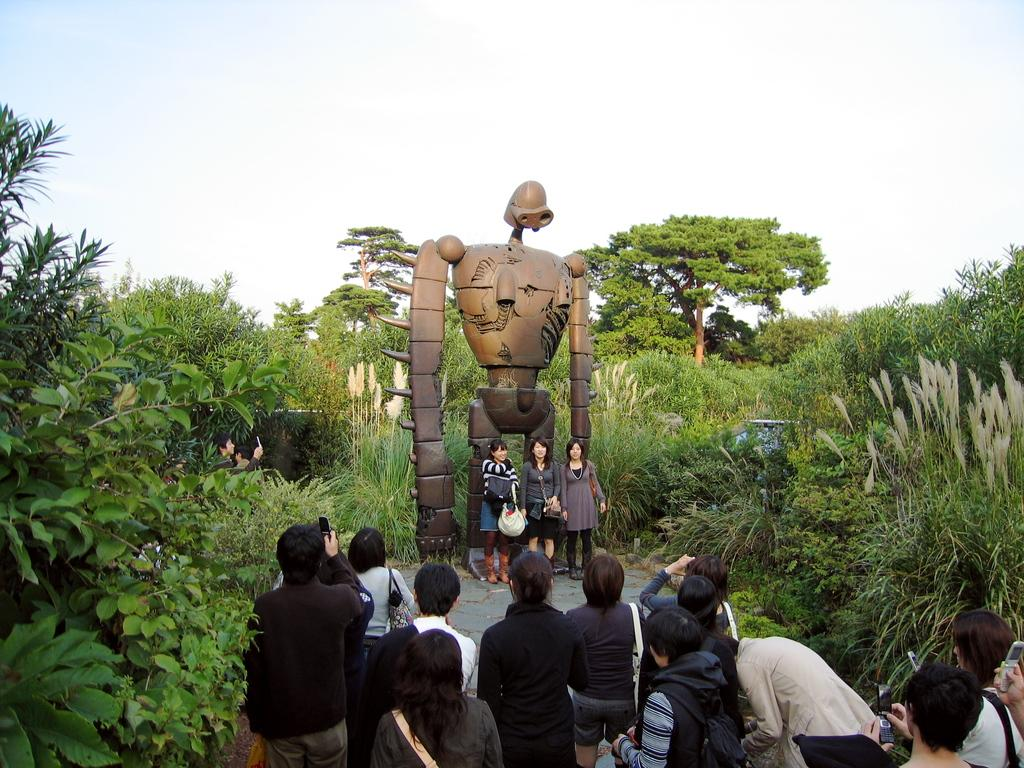How many people are in the image? There are many people in the image. What is located in the front of the image? There is a statue in the front of the image. What does the statue resemble? The statue resembles a robot. What can be seen on either side of the statue? There are plants to the left and right of the statue. What is visible in the background of the image? There are many trees in the background of the image. Where is the bomb hidden in the image? There is no bomb present in the image. What type of scene is depicted in the image? The image does not depict a specific scene; it shows a statue with people and plants around it. 